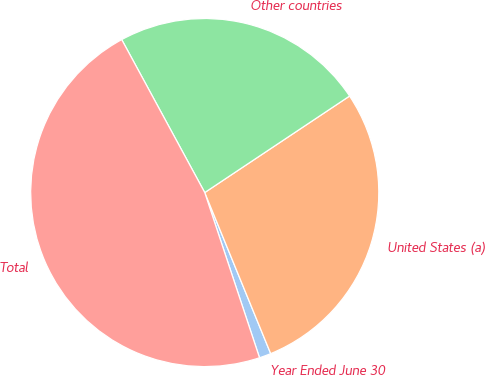Convert chart. <chart><loc_0><loc_0><loc_500><loc_500><pie_chart><fcel>Year Ended June 30<fcel>United States (a)<fcel>Other countries<fcel>Total<nl><fcel>1.09%<fcel>28.17%<fcel>23.56%<fcel>47.18%<nl></chart> 